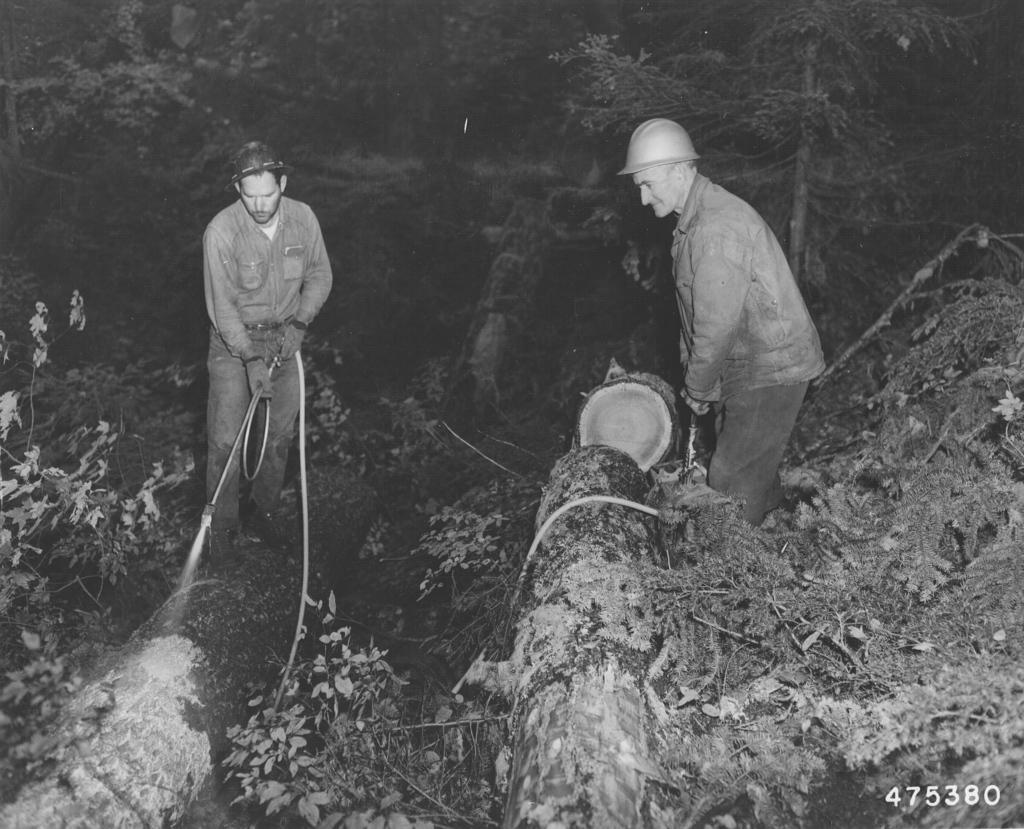How would you summarize this image in a sentence or two? In this image I can see two persons are holding a pipe and a tree trunk in hand on grass. In the background I can see trees. This image is taken may be during night in the forest. 